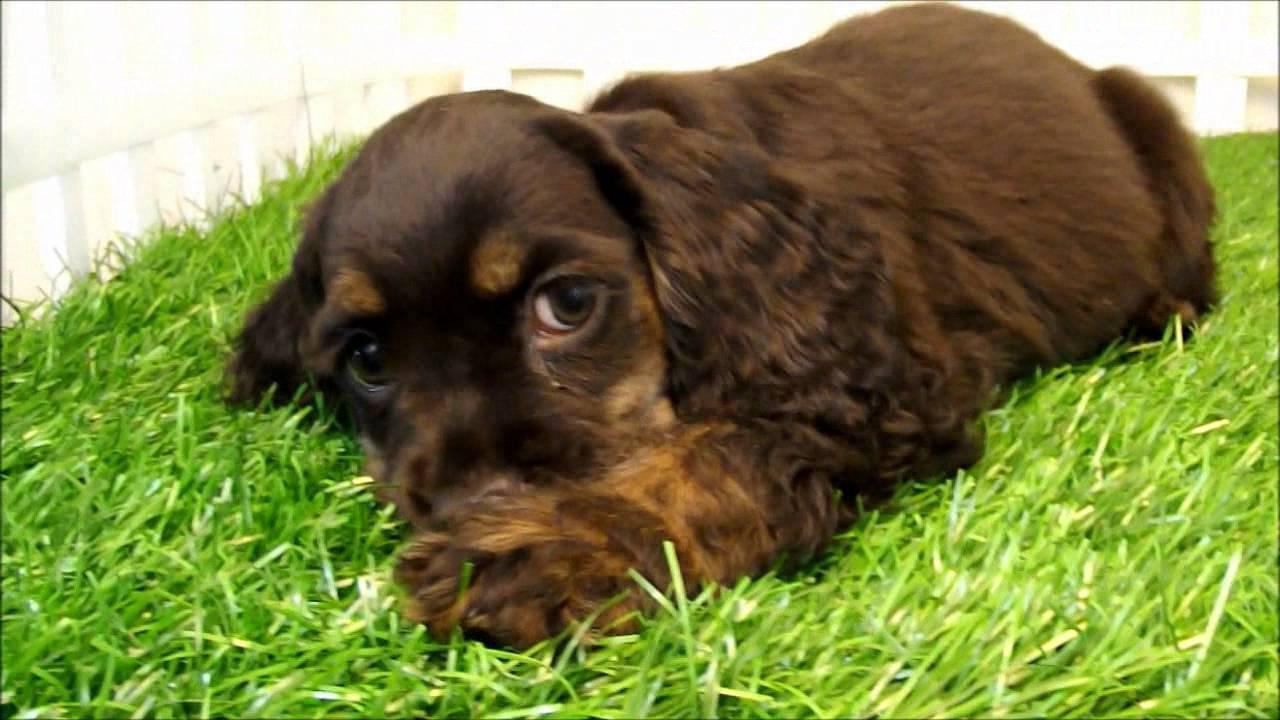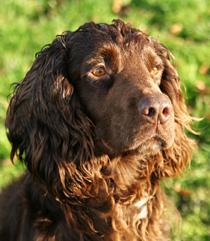The first image is the image on the left, the second image is the image on the right. Evaluate the accuracy of this statement regarding the images: "In one of the images the dog is lying down.". Is it true? Answer yes or no. Yes. 